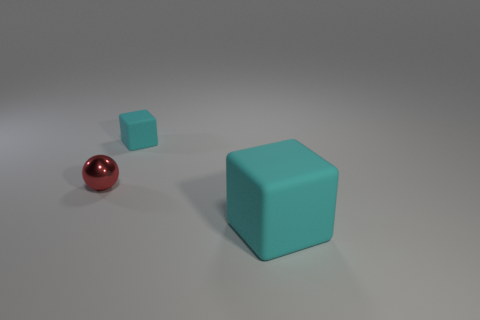Add 1 small cyan matte cubes. How many objects exist? 4 Subtract all cubes. How many objects are left? 1 Add 2 cyan matte cubes. How many cyan matte cubes exist? 4 Subtract 0 red cubes. How many objects are left? 3 Subtract all yellow cylinders. Subtract all large cyan blocks. How many objects are left? 2 Add 1 cyan blocks. How many cyan blocks are left? 3 